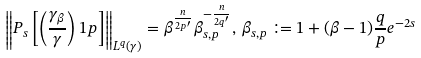Convert formula to latex. <formula><loc_0><loc_0><loc_500><loc_500>\left \| P _ { s } \left [ \left ( \frac { \gamma _ { \beta } } { \gamma } \right ) ^ { } { 1 } p \right ] \right \| _ { L ^ { q } ( \gamma ) } = \beta ^ { \frac { n } { 2 p ^ { \prime } } } \beta _ { s , p } ^ { - \frac { n } { 2 q ^ { \prime } } } , \, \beta _ { s , p } \coloneqq 1 + ( \beta - 1 ) \frac { q } { p } e ^ { - 2 s }</formula> 